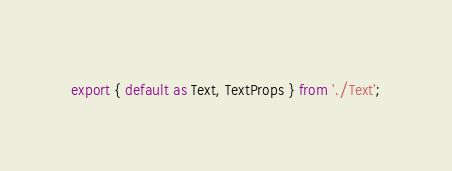<code> <loc_0><loc_0><loc_500><loc_500><_TypeScript_>export { default as Text, TextProps } from './Text';
</code> 